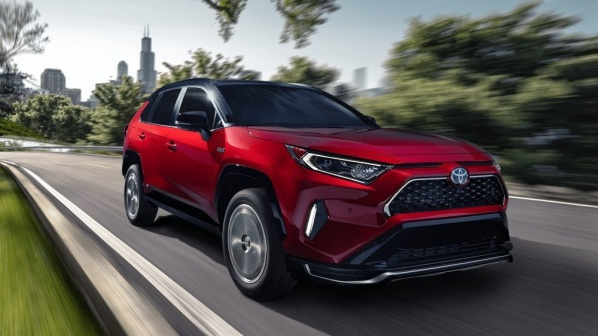How does the car's design reflect the brand's identity? The red Toyota RAV4's design reflects the brand's identity through its emphasis on reliability, innovation, and modern aesthetics. The bold, yet practical styling with a well-crafted grille and sleek lines signifies Toyota's commitment to combining functionality with a contemporary design language. This SUV is crafted to appeal to urban drivers who value both performance and style, embodying the brand's ethos of providing versatile, dependable, and advanced vehicles. 
Can you give more details about the background setting around the car? The background setting around the car includes a cityscape with a few tall buildings that suggest a metropolitan area. There are also several trees, indicating that the city might be well-integrated with green spaces. The road is smoothly paved and curves slightly, suggesting a well-maintained urban infrastructure. The blurred effect in the background gives a sense of speed and motion, reinforcing the dynamic nature of the scene. The city appears modern and bustling, but the focus remains on the red Toyota RAV4, which is prominently positioned in the foreground, highlighting its importance and central role in this environment. 